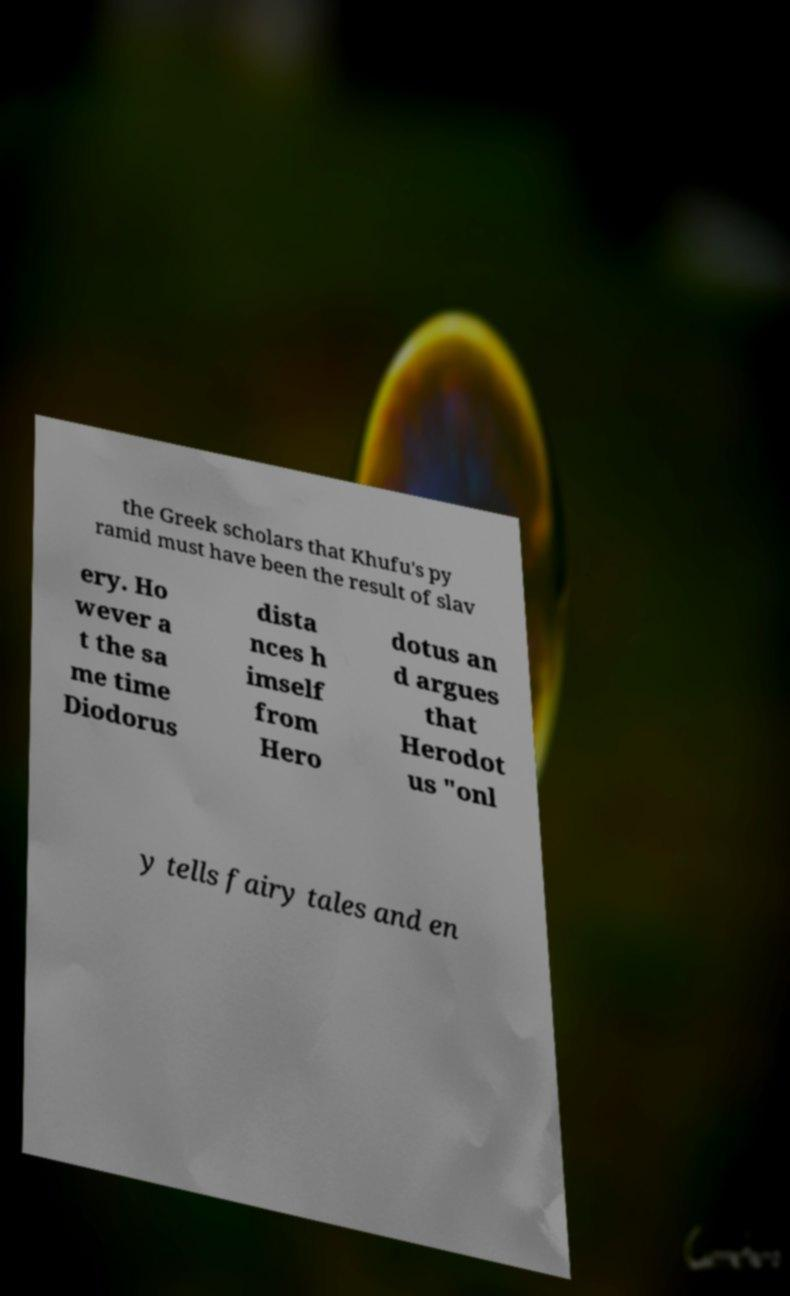Can you accurately transcribe the text from the provided image for me? the Greek scholars that Khufu's py ramid must have been the result of slav ery. Ho wever a t the sa me time Diodorus dista nces h imself from Hero dotus an d argues that Herodot us "onl y tells fairy tales and en 